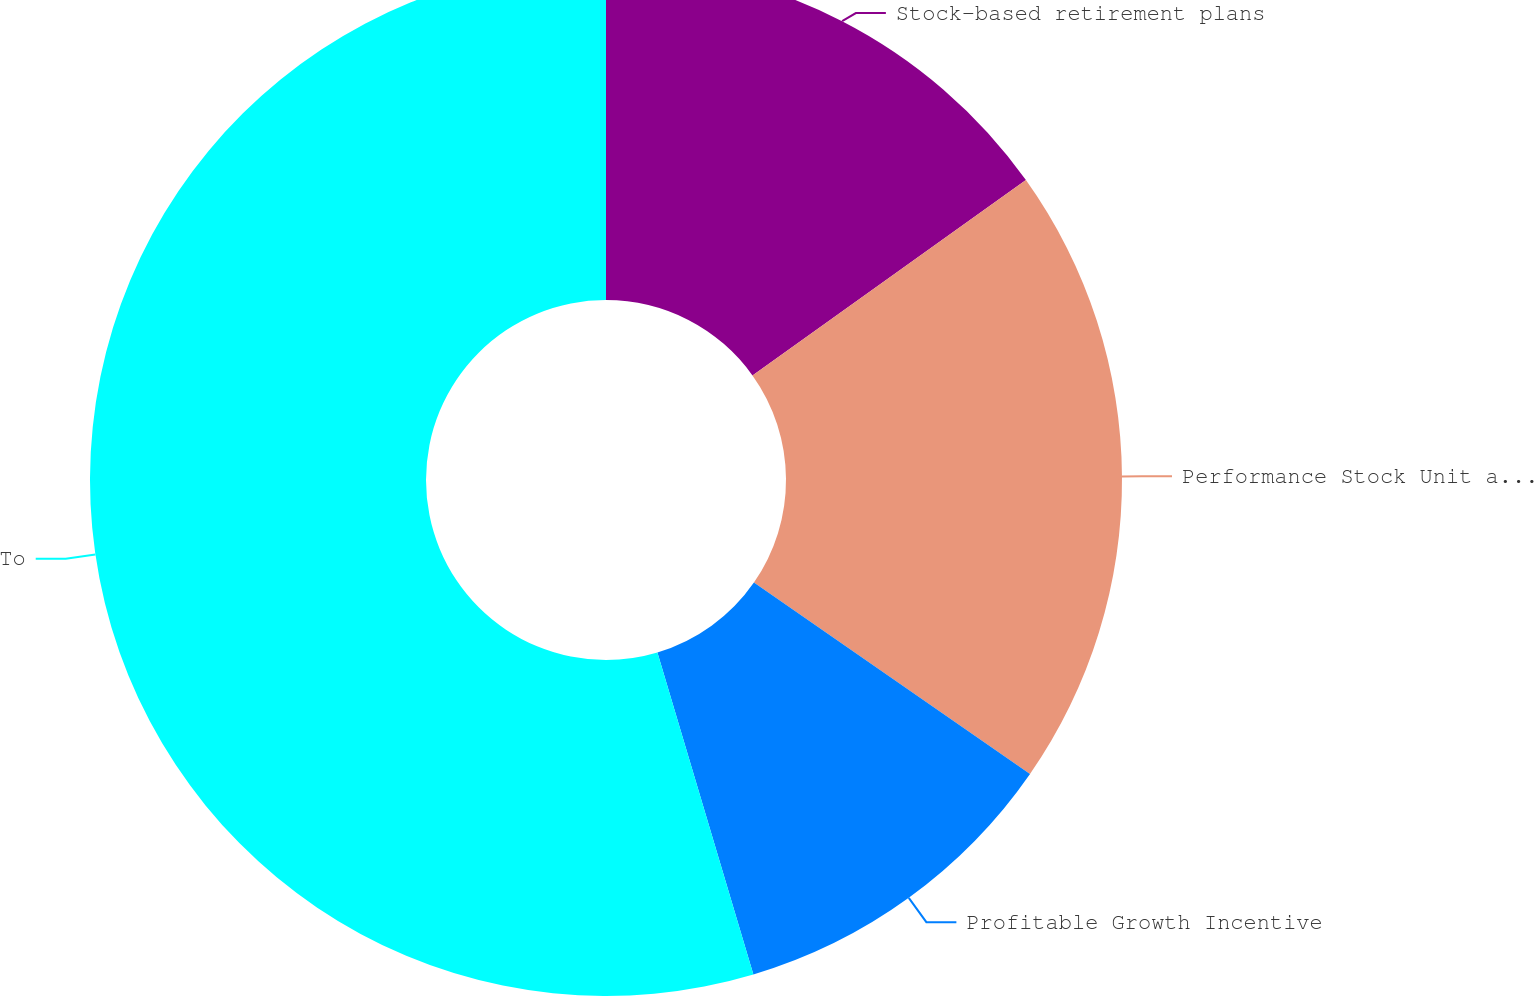<chart> <loc_0><loc_0><loc_500><loc_500><pie_chart><fcel>Stock-based retirement plans<fcel>Performance Stock Unit awards<fcel>Profitable Growth Incentive<fcel>Total stock-based compensation<nl><fcel>15.13%<fcel>19.52%<fcel>10.74%<fcel>54.61%<nl></chart> 